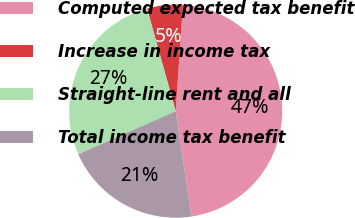<chart> <loc_0><loc_0><loc_500><loc_500><pie_chart><fcel>Computed expected tax benefit<fcel>Increase in income tax<fcel>Straight-line rent and all<fcel>Total income tax benefit<nl><fcel>46.56%<fcel>5.42%<fcel>27.3%<fcel>20.72%<nl></chart> 